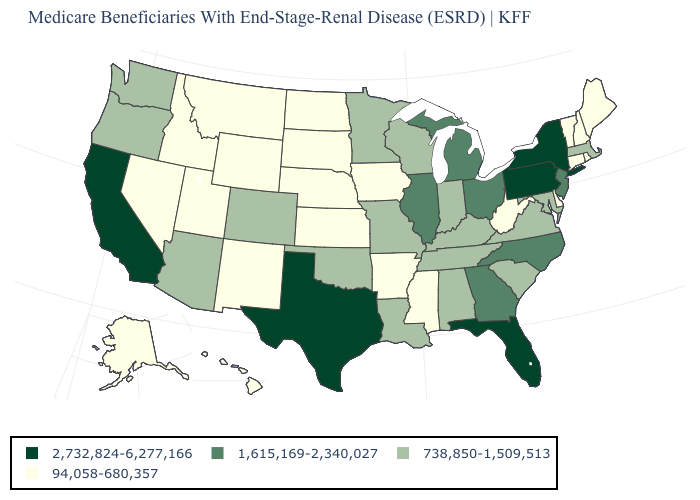Name the states that have a value in the range 94,058-680,357?
Concise answer only. Alaska, Arkansas, Connecticut, Delaware, Hawaii, Idaho, Iowa, Kansas, Maine, Mississippi, Montana, Nebraska, Nevada, New Hampshire, New Mexico, North Dakota, Rhode Island, South Dakota, Utah, Vermont, West Virginia, Wyoming. What is the value of Oklahoma?
Write a very short answer. 738,850-1,509,513. What is the value of Nebraska?
Short answer required. 94,058-680,357. How many symbols are there in the legend?
Keep it brief. 4. Name the states that have a value in the range 2,732,824-6,277,166?
Keep it brief. California, Florida, New York, Pennsylvania, Texas. Name the states that have a value in the range 94,058-680,357?
Write a very short answer. Alaska, Arkansas, Connecticut, Delaware, Hawaii, Idaho, Iowa, Kansas, Maine, Mississippi, Montana, Nebraska, Nevada, New Hampshire, New Mexico, North Dakota, Rhode Island, South Dakota, Utah, Vermont, West Virginia, Wyoming. Name the states that have a value in the range 1,615,169-2,340,027?
Quick response, please. Georgia, Illinois, Michigan, New Jersey, North Carolina, Ohio. Does Wisconsin have the same value as Alabama?
Be succinct. Yes. Does the first symbol in the legend represent the smallest category?
Concise answer only. No. What is the highest value in the West ?
Answer briefly. 2,732,824-6,277,166. What is the value of Wyoming?
Be succinct. 94,058-680,357. What is the highest value in states that border Nevada?
Answer briefly. 2,732,824-6,277,166. Which states hav the highest value in the South?
Keep it brief. Florida, Texas. Name the states that have a value in the range 738,850-1,509,513?
Answer briefly. Alabama, Arizona, Colorado, Indiana, Kentucky, Louisiana, Maryland, Massachusetts, Minnesota, Missouri, Oklahoma, Oregon, South Carolina, Tennessee, Virginia, Washington, Wisconsin. What is the value of Massachusetts?
Be succinct. 738,850-1,509,513. 